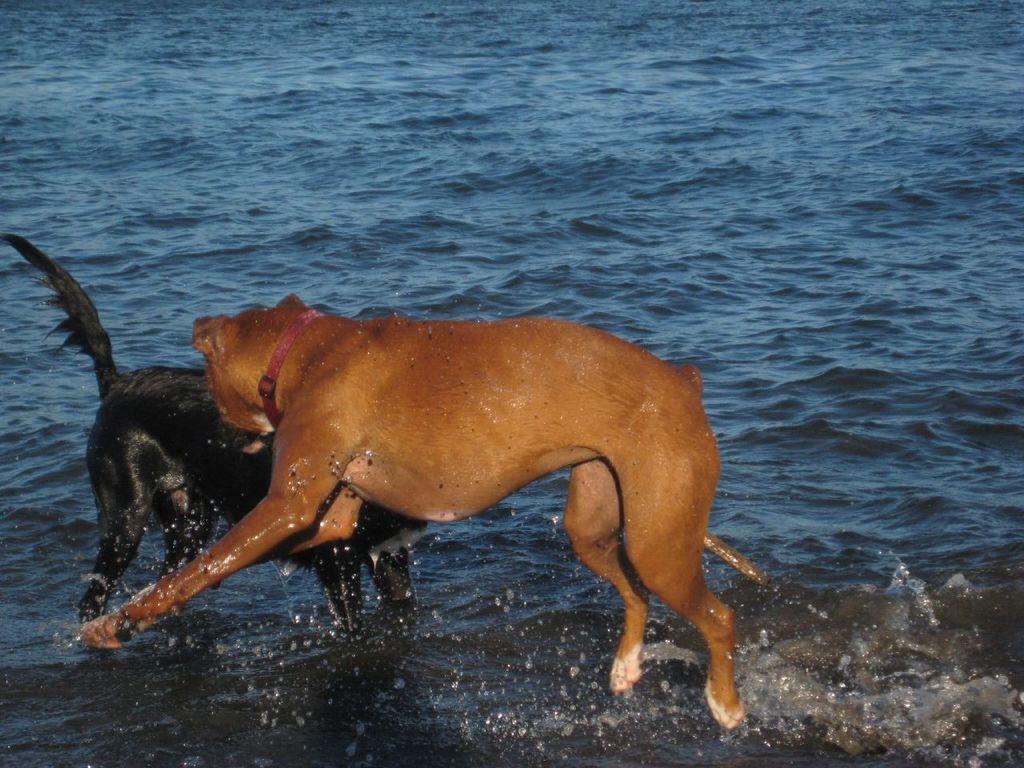In one or two sentences, can you explain what this image depicts? Here I can see two dogs in the water. It seems like they are fighting. 